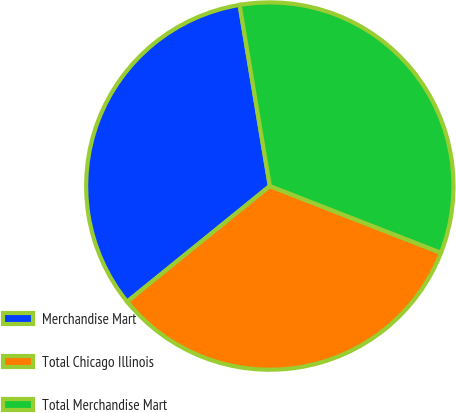<chart> <loc_0><loc_0><loc_500><loc_500><pie_chart><fcel>Merchandise Mart<fcel>Total Chicago Illinois<fcel>Total Merchandise Mart<nl><fcel>33.21%<fcel>33.24%<fcel>33.55%<nl></chart> 